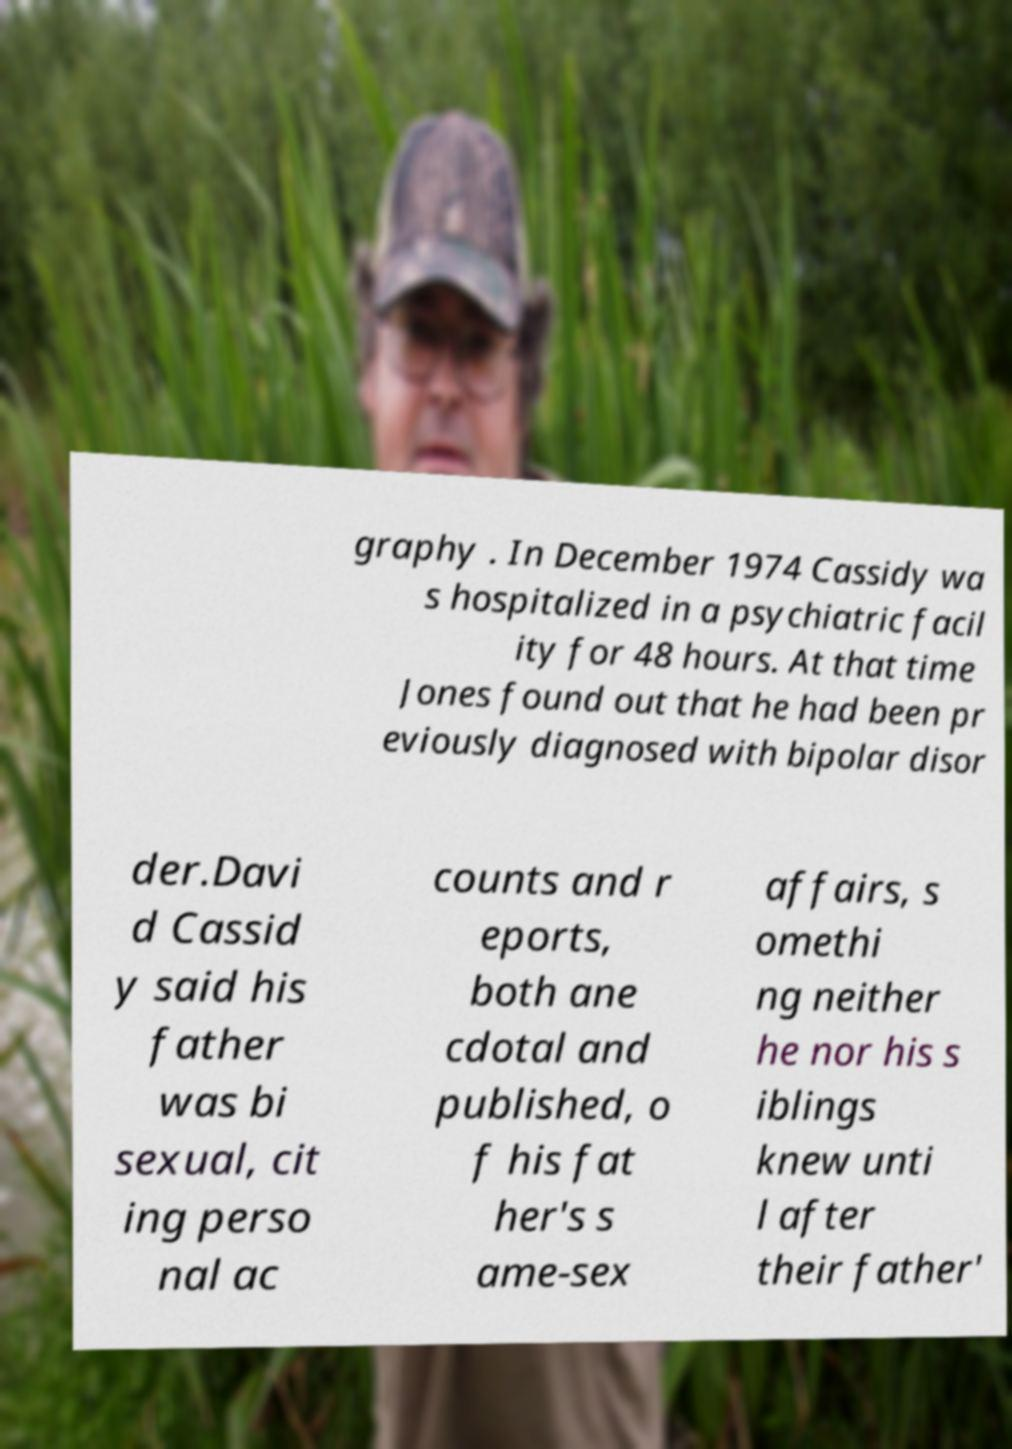Can you accurately transcribe the text from the provided image for me? graphy . In December 1974 Cassidy wa s hospitalized in a psychiatric facil ity for 48 hours. At that time Jones found out that he had been pr eviously diagnosed with bipolar disor der.Davi d Cassid y said his father was bi sexual, cit ing perso nal ac counts and r eports, both ane cdotal and published, o f his fat her's s ame-sex affairs, s omethi ng neither he nor his s iblings knew unti l after their father' 